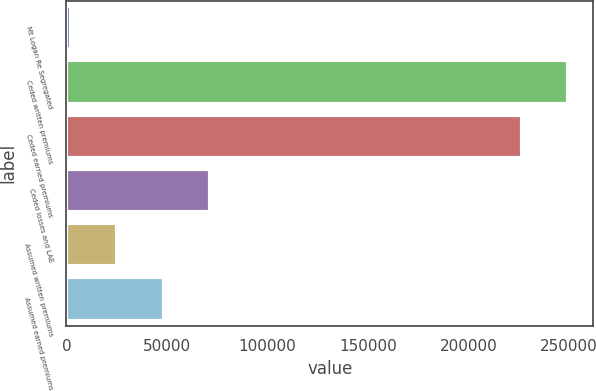Convert chart to OTSL. <chart><loc_0><loc_0><loc_500><loc_500><bar_chart><fcel>Mt Logan Re Segregated<fcel>Ceded written premiums<fcel>Ceded earned premiums<fcel>Ceded losses and LAE<fcel>Assumed written premiums<fcel>Assumed earned premiums<nl><fcel>2015<fcel>249584<fcel>226385<fcel>71610.8<fcel>25213.6<fcel>48412.2<nl></chart> 